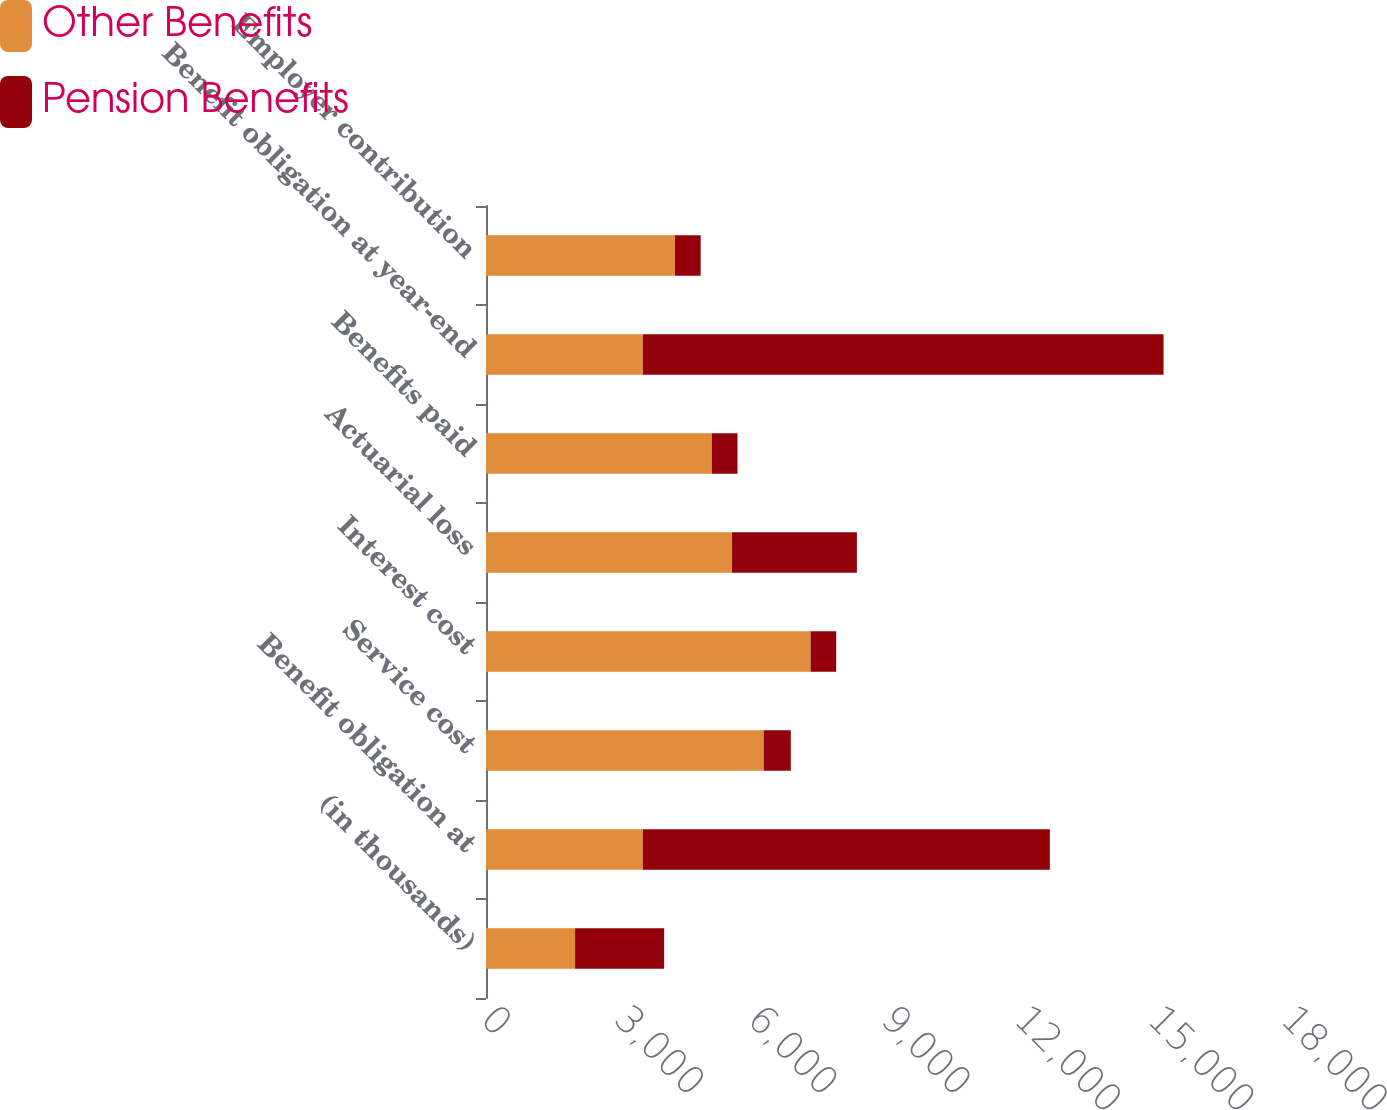<chart> <loc_0><loc_0><loc_500><loc_500><stacked_bar_chart><ecel><fcel>(in thousands)<fcel>Benefit obligation at<fcel>Service cost<fcel>Interest cost<fcel>Actuarial loss<fcel>Benefits paid<fcel>Benefit obligation at year-end<fcel>Employer contribution<nl><fcel>Other Benefits<fcel>2004<fcel>3530.5<fcel>6248<fcel>7303<fcel>5536<fcel>5081<fcel>3530.5<fcel>4252<nl><fcel>Pension Benefits<fcel>2004<fcel>9156<fcel>610<fcel>577<fcel>2809<fcel>578<fcel>11715<fcel>578<nl></chart> 